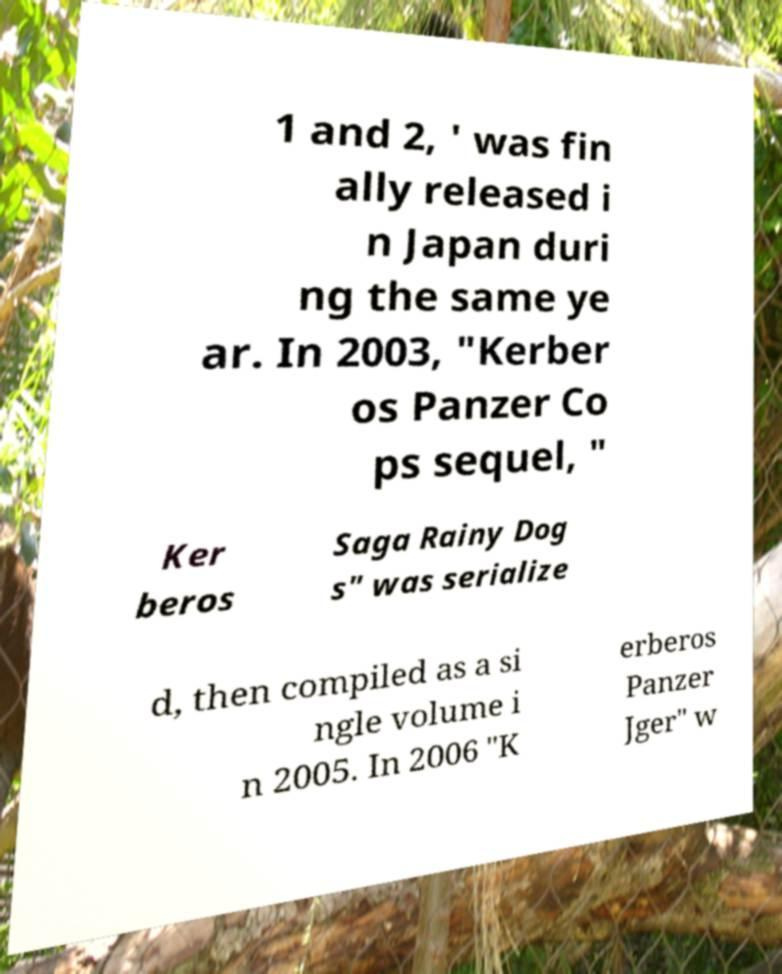What messages or text are displayed in this image? I need them in a readable, typed format. 1 and 2, ' was fin ally released i n Japan duri ng the same ye ar. In 2003, "Kerber os Panzer Co ps sequel, " Ker beros Saga Rainy Dog s" was serialize d, then compiled as a si ngle volume i n 2005. In 2006 "K erberos Panzer Jger" w 